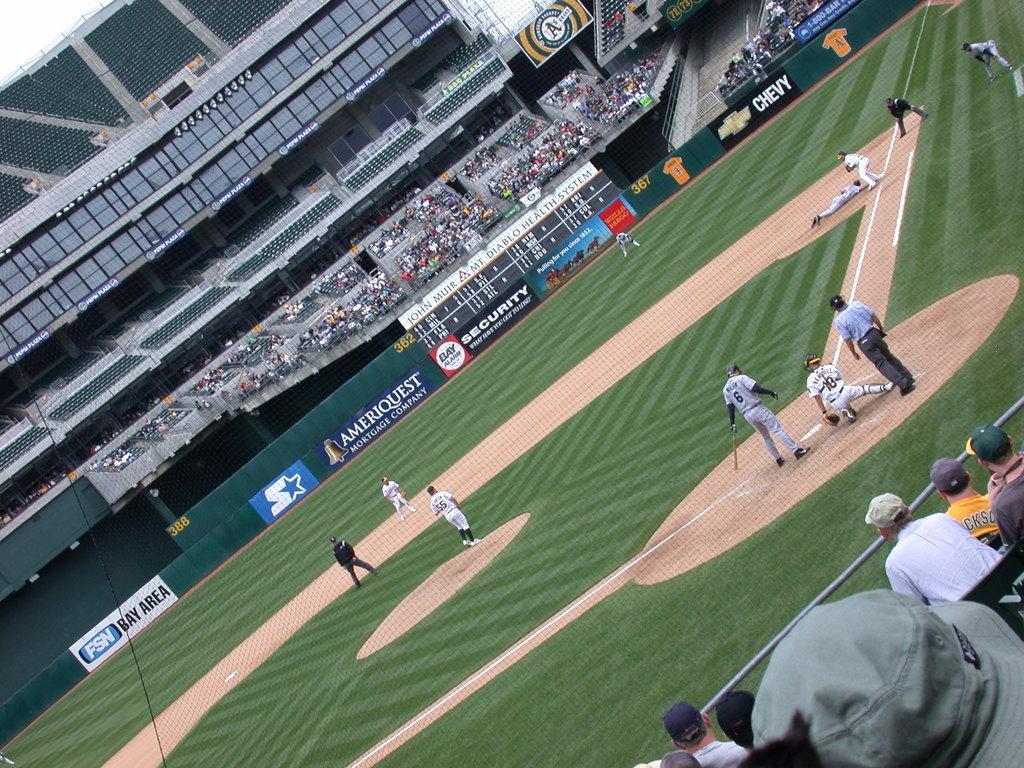What mortgage company is a sponsor?
Give a very brief answer. Ameriquest. What car manufacturer is depicted on the backwall?
Keep it short and to the point. Chevy. 